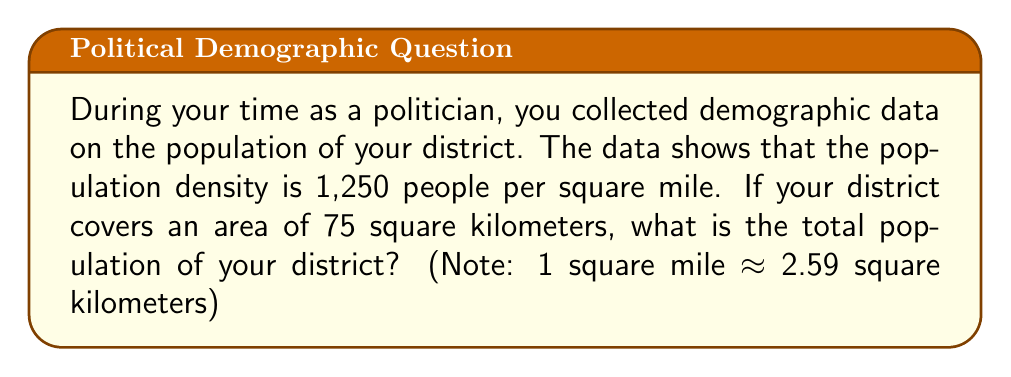Solve this math problem. To solve this problem, we need to follow these steps:

1) First, we need to convert the area from square kilometers to square miles:
   $$ 75 \text{ km}^2 \times \frac{1 \text{ mile}^2}{2.59 \text{ km}^2} \approx 28.96 \text{ miles}^2 $$

2) Now that we have the area in square miles, we can use the population density to calculate the total population:
   $$ \text{Population} = \text{Population Density} \times \text{Area} $$
   $$ \text{Population} = 1,250 \text{ people/mile}^2 \times 28.96 \text{ miles}^2 $$
   $$ \text{Population} = 36,200 \text{ people} $$

3) Rounding to the nearest hundred (as is common in demographic statistics):
   $$ \text{Population} \approx 36,200 \text{ people} $$
Answer: 36,200 people 